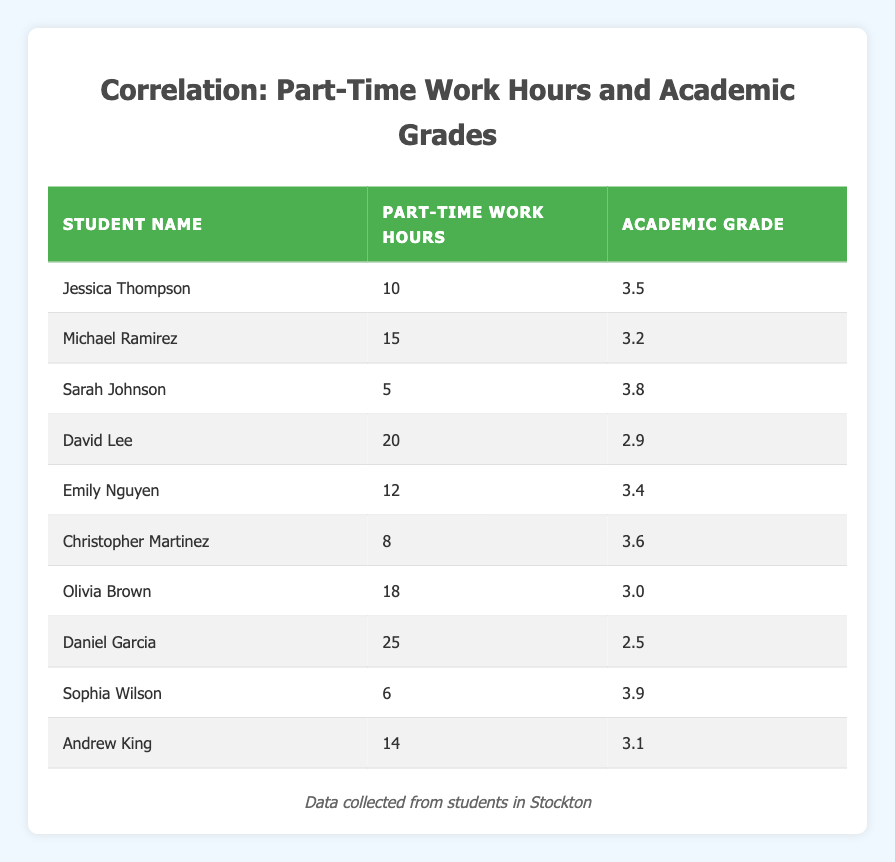What is the academic grade of Sarah Johnson? The table lists Sarah Johnson under the students' names, and her academic grade is stated as 3.8.
Answer: 3.8 How many part-time work hours does Daniel Garcia have? In the table, Daniel Garcia is listed with 25 part-time work hours.
Answer: 25 Is there a student with both part-time work hours and academic grades over 20 and 3.5 respectively? By reviewing the table, Daniel Garcia has 25 hours, but his grade is 2.5. No other students work over 20 hours, and their grades do not match the criteria. Hence, the answer is no.
Answer: No What is the average academic grade of students who work less than 10 hours? The students who work less than 10 hours are Jessica Thompson (3.5), Christopher Martinez (3.6), and Sophia Wilson (3.9). Adding these grades gives a total of 3.5 + 3.6 + 3.9 = 11.0. Dividing by the number of students (3) gives an average of 11.0 / 3 = 3.67.
Answer: 3.67 Which student has the lowest academic grade, and what is their part-time work hours? scanning through the table, Daniel Garcia has the lowest grade of 2.5, and he works 25 hours.
Answer: Daniel Garcia, 25 hours How many students have academic grades greater than 3.5? The students with grades greater than 3.5 are Sarah Johnson (3.8), Jessica Thompson (3.5), Emily Nguyen (3.4), Christopher Martinez (3.6), and Sophia Wilson (3.9). In total, there are five students.
Answer: 5 What is the difference in academic grades between the student with the most work hours and the student with the least work hours? Daniel Garcia works the most at 25 hours with a grade of 2.5, while Sarah Johnson works the least at 5 hours with a grade of 3.8. The difference is 3.8 - 2.5 = 1.3.
Answer: 1.3 Which student has a work hour count closest to the median of all part-time work hours? The total work hours listed are 5, 6, 8, 10, 12, 14, 15, 18, 20, and 25. The median is found between the 5th and 6th values in sorted order (12 and 14), which averages to 13. The student with the closest hours is Andrew King with 14 hours.
Answer: Andrew King How many students work between 15 and 20 hours? We look at students who have work hours between 15 and 20. The applicable students are Michael Ramirez (15), David Lee (20), and Olivia Brown (18). Thus, there are three students.
Answer: 3 